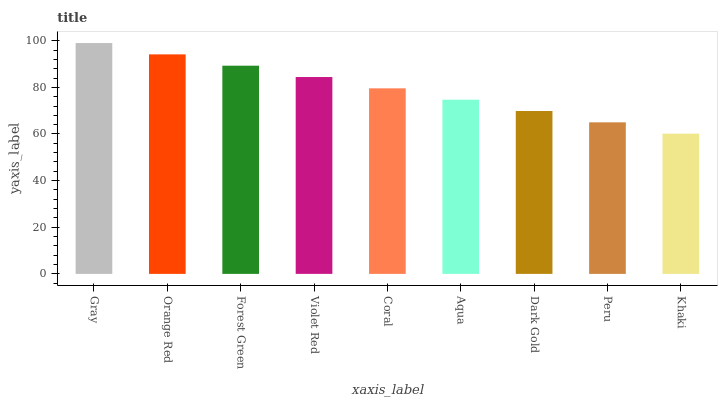Is Khaki the minimum?
Answer yes or no. Yes. Is Gray the maximum?
Answer yes or no. Yes. Is Orange Red the minimum?
Answer yes or no. No. Is Orange Red the maximum?
Answer yes or no. No. Is Gray greater than Orange Red?
Answer yes or no. Yes. Is Orange Red less than Gray?
Answer yes or no. Yes. Is Orange Red greater than Gray?
Answer yes or no. No. Is Gray less than Orange Red?
Answer yes or no. No. Is Coral the high median?
Answer yes or no. Yes. Is Coral the low median?
Answer yes or no. Yes. Is Violet Red the high median?
Answer yes or no. No. Is Khaki the low median?
Answer yes or no. No. 